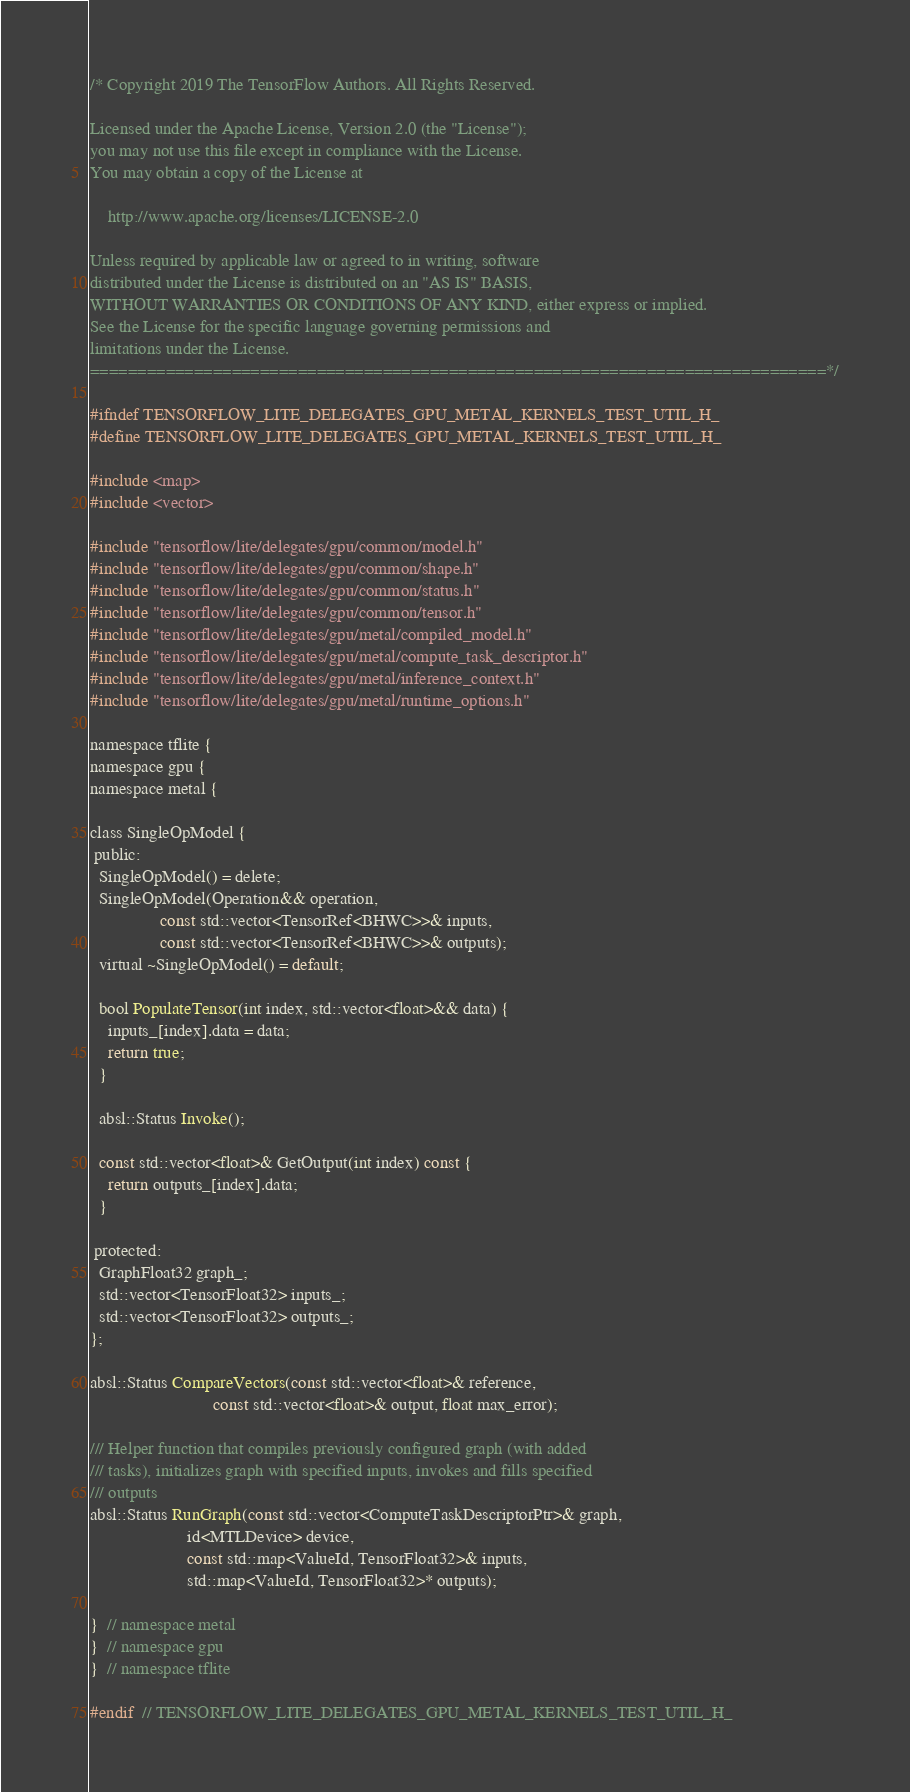Convert code to text. <code><loc_0><loc_0><loc_500><loc_500><_C_>/* Copyright 2019 The TensorFlow Authors. All Rights Reserved.

Licensed under the Apache License, Version 2.0 (the "License");
you may not use this file except in compliance with the License.
You may obtain a copy of the License at

    http://www.apache.org/licenses/LICENSE-2.0

Unless required by applicable law or agreed to in writing, software
distributed under the License is distributed on an "AS IS" BASIS,
WITHOUT WARRANTIES OR CONDITIONS OF ANY KIND, either express or implied.
See the License for the specific language governing permissions and
limitations under the License.
==============================================================================*/

#ifndef TENSORFLOW_LITE_DELEGATES_GPU_METAL_KERNELS_TEST_UTIL_H_
#define TENSORFLOW_LITE_DELEGATES_GPU_METAL_KERNELS_TEST_UTIL_H_

#include <map>
#include <vector>

#include "tensorflow/lite/delegates/gpu/common/model.h"
#include "tensorflow/lite/delegates/gpu/common/shape.h"
#include "tensorflow/lite/delegates/gpu/common/status.h"
#include "tensorflow/lite/delegates/gpu/common/tensor.h"
#include "tensorflow/lite/delegates/gpu/metal/compiled_model.h"
#include "tensorflow/lite/delegates/gpu/metal/compute_task_descriptor.h"
#include "tensorflow/lite/delegates/gpu/metal/inference_context.h"
#include "tensorflow/lite/delegates/gpu/metal/runtime_options.h"

namespace tflite {
namespace gpu {
namespace metal {

class SingleOpModel {
 public:
  SingleOpModel() = delete;
  SingleOpModel(Operation&& operation,
                const std::vector<TensorRef<BHWC>>& inputs,
                const std::vector<TensorRef<BHWC>>& outputs);
  virtual ~SingleOpModel() = default;

  bool PopulateTensor(int index, std::vector<float>&& data) {
    inputs_[index].data = data;
    return true;
  }

  absl::Status Invoke();

  const std::vector<float>& GetOutput(int index) const {
    return outputs_[index].data;
  }

 protected:
  GraphFloat32 graph_;
  std::vector<TensorFloat32> inputs_;
  std::vector<TensorFloat32> outputs_;
};

absl::Status CompareVectors(const std::vector<float>& reference,
                            const std::vector<float>& output, float max_error);

/// Helper function that compiles previously configured graph (with added
/// tasks), initializes graph with specified inputs, invokes and fills specified
/// outputs
absl::Status RunGraph(const std::vector<ComputeTaskDescriptorPtr>& graph,
                      id<MTLDevice> device,
                      const std::map<ValueId, TensorFloat32>& inputs,
                      std::map<ValueId, TensorFloat32>* outputs);

}  // namespace metal
}  // namespace gpu
}  // namespace tflite

#endif  // TENSORFLOW_LITE_DELEGATES_GPU_METAL_KERNELS_TEST_UTIL_H_
</code> 